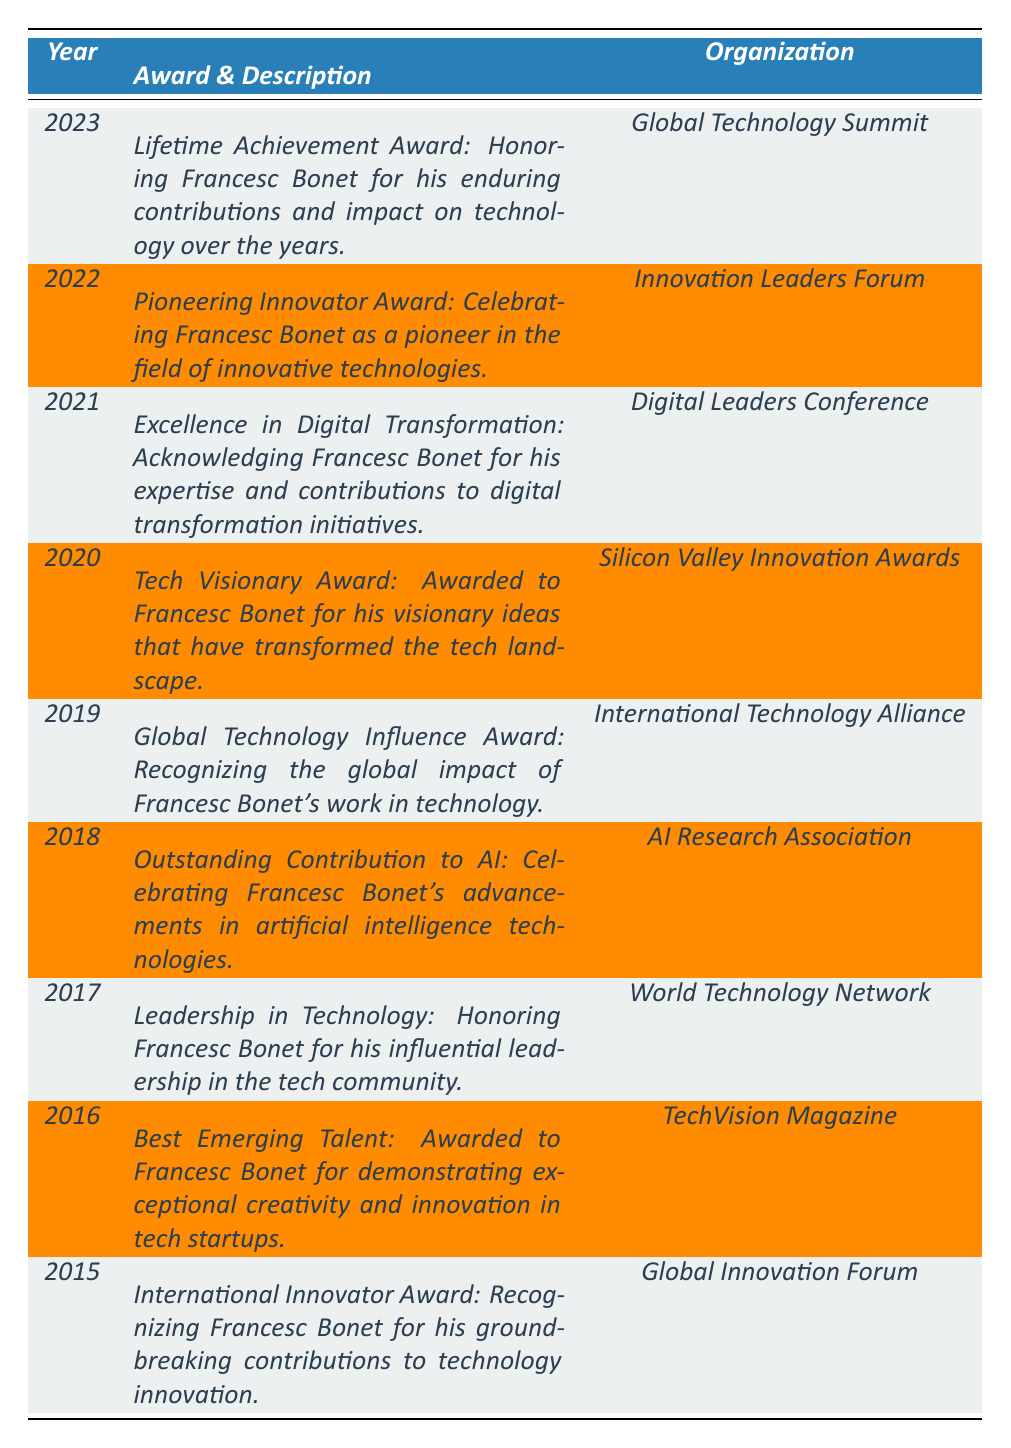What award did Francesc Bonet receive in 2023? The table states that in 2023, Francesc Bonet received the "Lifetime Achievement Award."
Answer: Lifetime Achievement Award Which organization awarded Francesc Bonet the "Excellence in Digital Transformation"? The table indicates that the "Excellence in Digital Transformation" award was given by the "Digital Leaders Conference."
Answer: Digital Leaders Conference How many awards did Francesc Bonet receive from 2015 to 2023? The table lists 9 awards received by Francesc Bonet from 2015 to 2023, counting each year in which he received an award.
Answer: 9 Was Francesc Bonet recognized for contributions to AI in any year? Yes, according to the table, he received the "Outstanding Contribution to AI" award in 2018.
Answer: Yes In which year did Francesc Bonet receive the "Tech Visionary Award"? The table shows that the "Tech Visionary Award" was awarded to him in 2020.
Answer: 2020 What is the earliest award Francesc Bonet received listed in the table? The table lists the "International Innovator Award" from 2015 as the earliest award.
Answer: International Innovator Award Were there any awards related to technology transformation during this time frame? Yes, the "Excellence in Digital Transformation" awarded in 2021 is related to technology transformation.
Answer: Yes Which award has the longest description? The "Lifetime Achievement Award" in 2023 has the longest description, stating Francesc Bonet's enduring contributions and impact on technology.
Answer: Lifetime Achievement Award How many awards were given by organizations that include the word "Innovation"? The awards from the "Global Innovation Forum," "Silicon Valley Innovation Awards," and "Innovation Leaders Forum" include the word "Innovation," totaling 3 awards.
Answer: 3 What was the trend in the number of awards received by Francesc Bonet over the years? By examining each year, we find that the number of awards remained consistent at one per year from 2015 to 2023, indicating steady recognition.
Answer: Steady recognition at one per year 